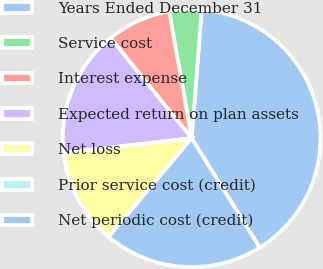Convert chart. <chart><loc_0><loc_0><loc_500><loc_500><pie_chart><fcel>Years Ended December 31<fcel>Service cost<fcel>Interest expense<fcel>Expected return on plan assets<fcel>Net loss<fcel>Prior service cost (credit)<fcel>Net periodic cost (credit)<nl><fcel>39.89%<fcel>4.04%<fcel>8.03%<fcel>15.99%<fcel>12.01%<fcel>0.06%<fcel>19.98%<nl></chart> 